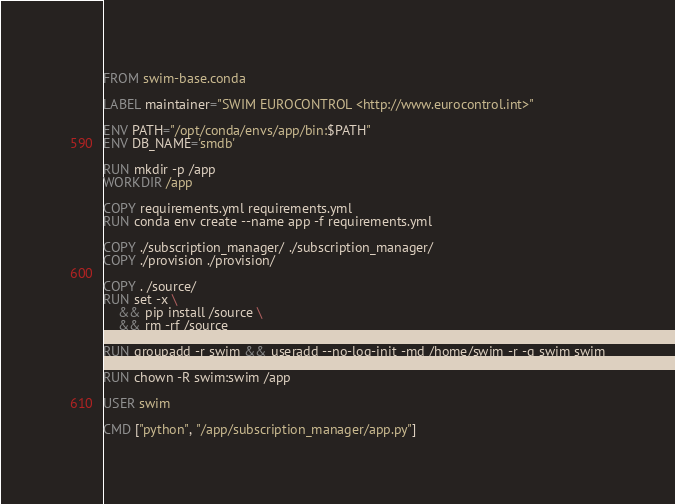Convert code to text. <code><loc_0><loc_0><loc_500><loc_500><_Dockerfile_>FROM swim-base.conda

LABEL maintainer="SWIM EUROCONTROL <http://www.eurocontrol.int>"

ENV PATH="/opt/conda/envs/app/bin:$PATH"
ENV DB_NAME='smdb'

RUN mkdir -p /app
WORKDIR /app

COPY requirements.yml requirements.yml
RUN conda env create --name app -f requirements.yml

COPY ./subscription_manager/ ./subscription_manager/
COPY ./provision ./provision/

COPY . /source/
RUN set -x \
    && pip install /source \
    && rm -rf /source

RUN groupadd -r swim && useradd --no-log-init -md /home/swim -r -g swim swim

RUN chown -R swim:swim /app

USER swim

CMD ["python", "/app/subscription_manager/app.py"]
</code> 